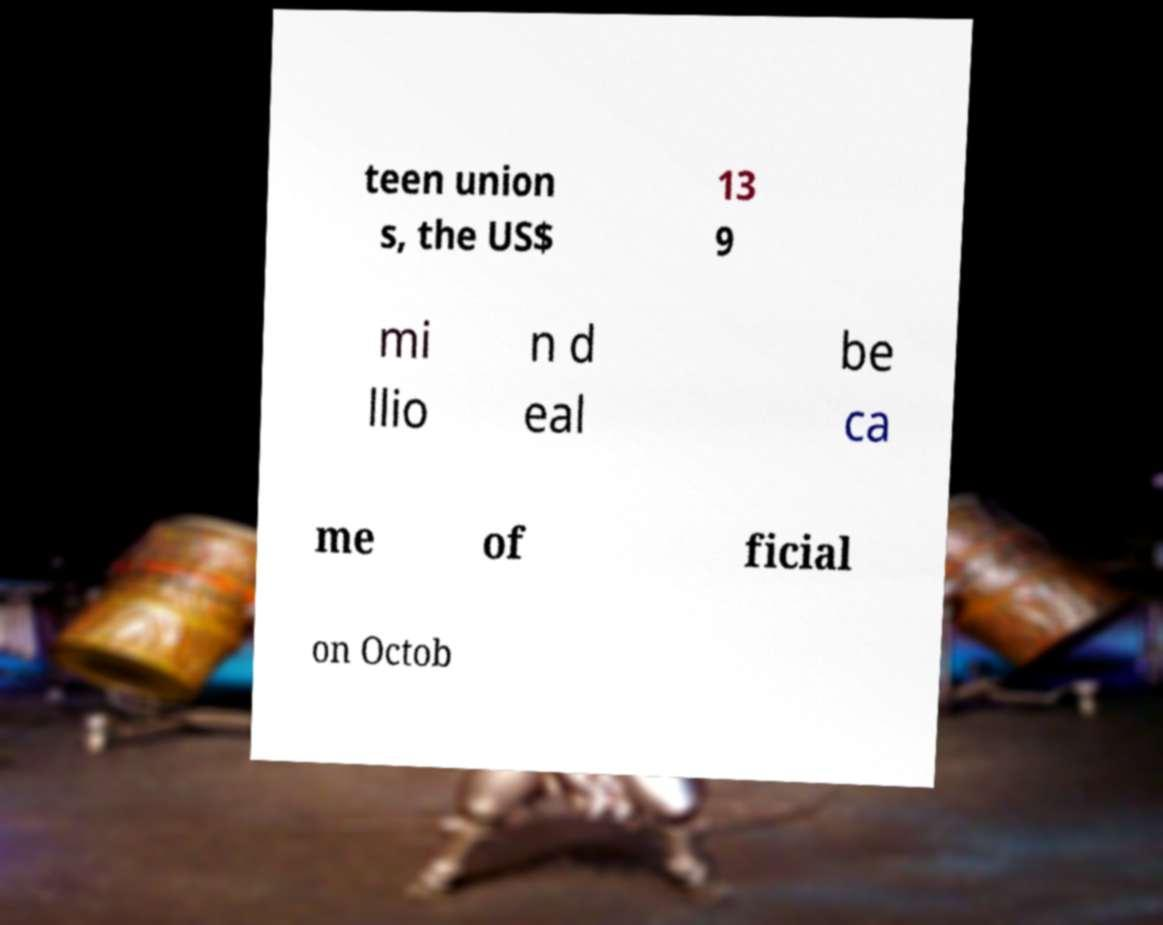Please identify and transcribe the text found in this image. teen union s, the US$ 13 9 mi llio n d eal be ca me of ficial on Octob 